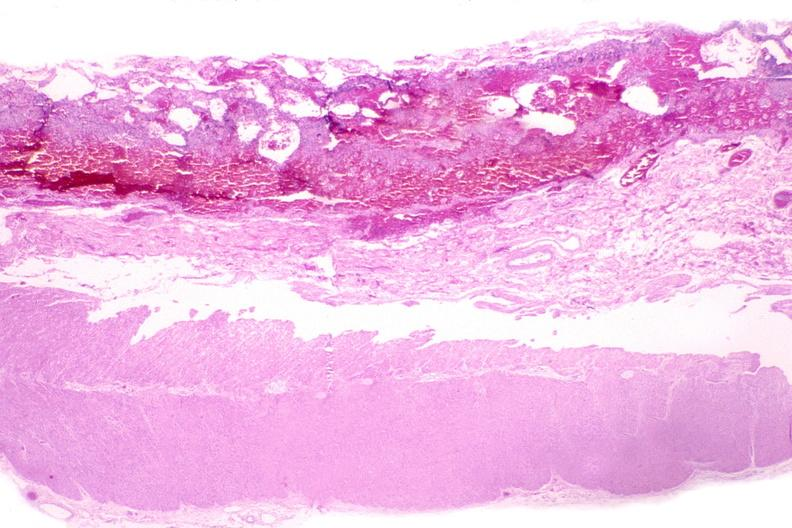where is this from?
Answer the question using a single word or phrase. Gastrointestinal system 